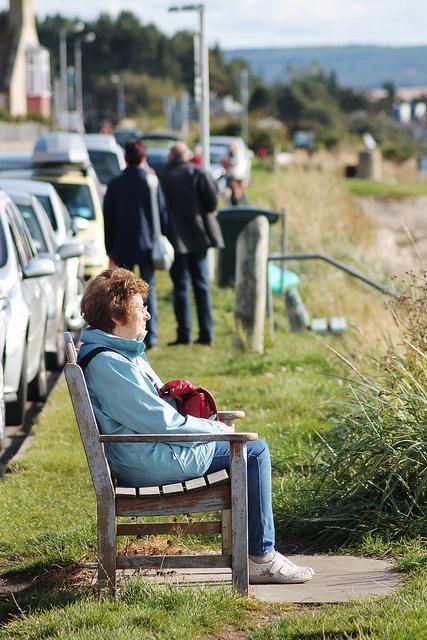How many cars are there?
Give a very brief answer. 5. How many people can you see?
Give a very brief answer. 3. 